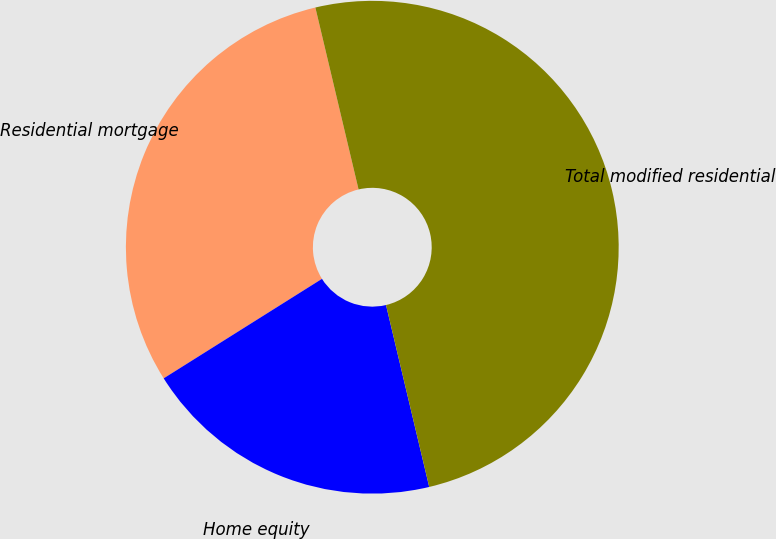<chart> <loc_0><loc_0><loc_500><loc_500><pie_chart><fcel>Residential mortgage<fcel>Home equity<fcel>Total modified residential<nl><fcel>30.22%<fcel>19.78%<fcel>50.0%<nl></chart> 